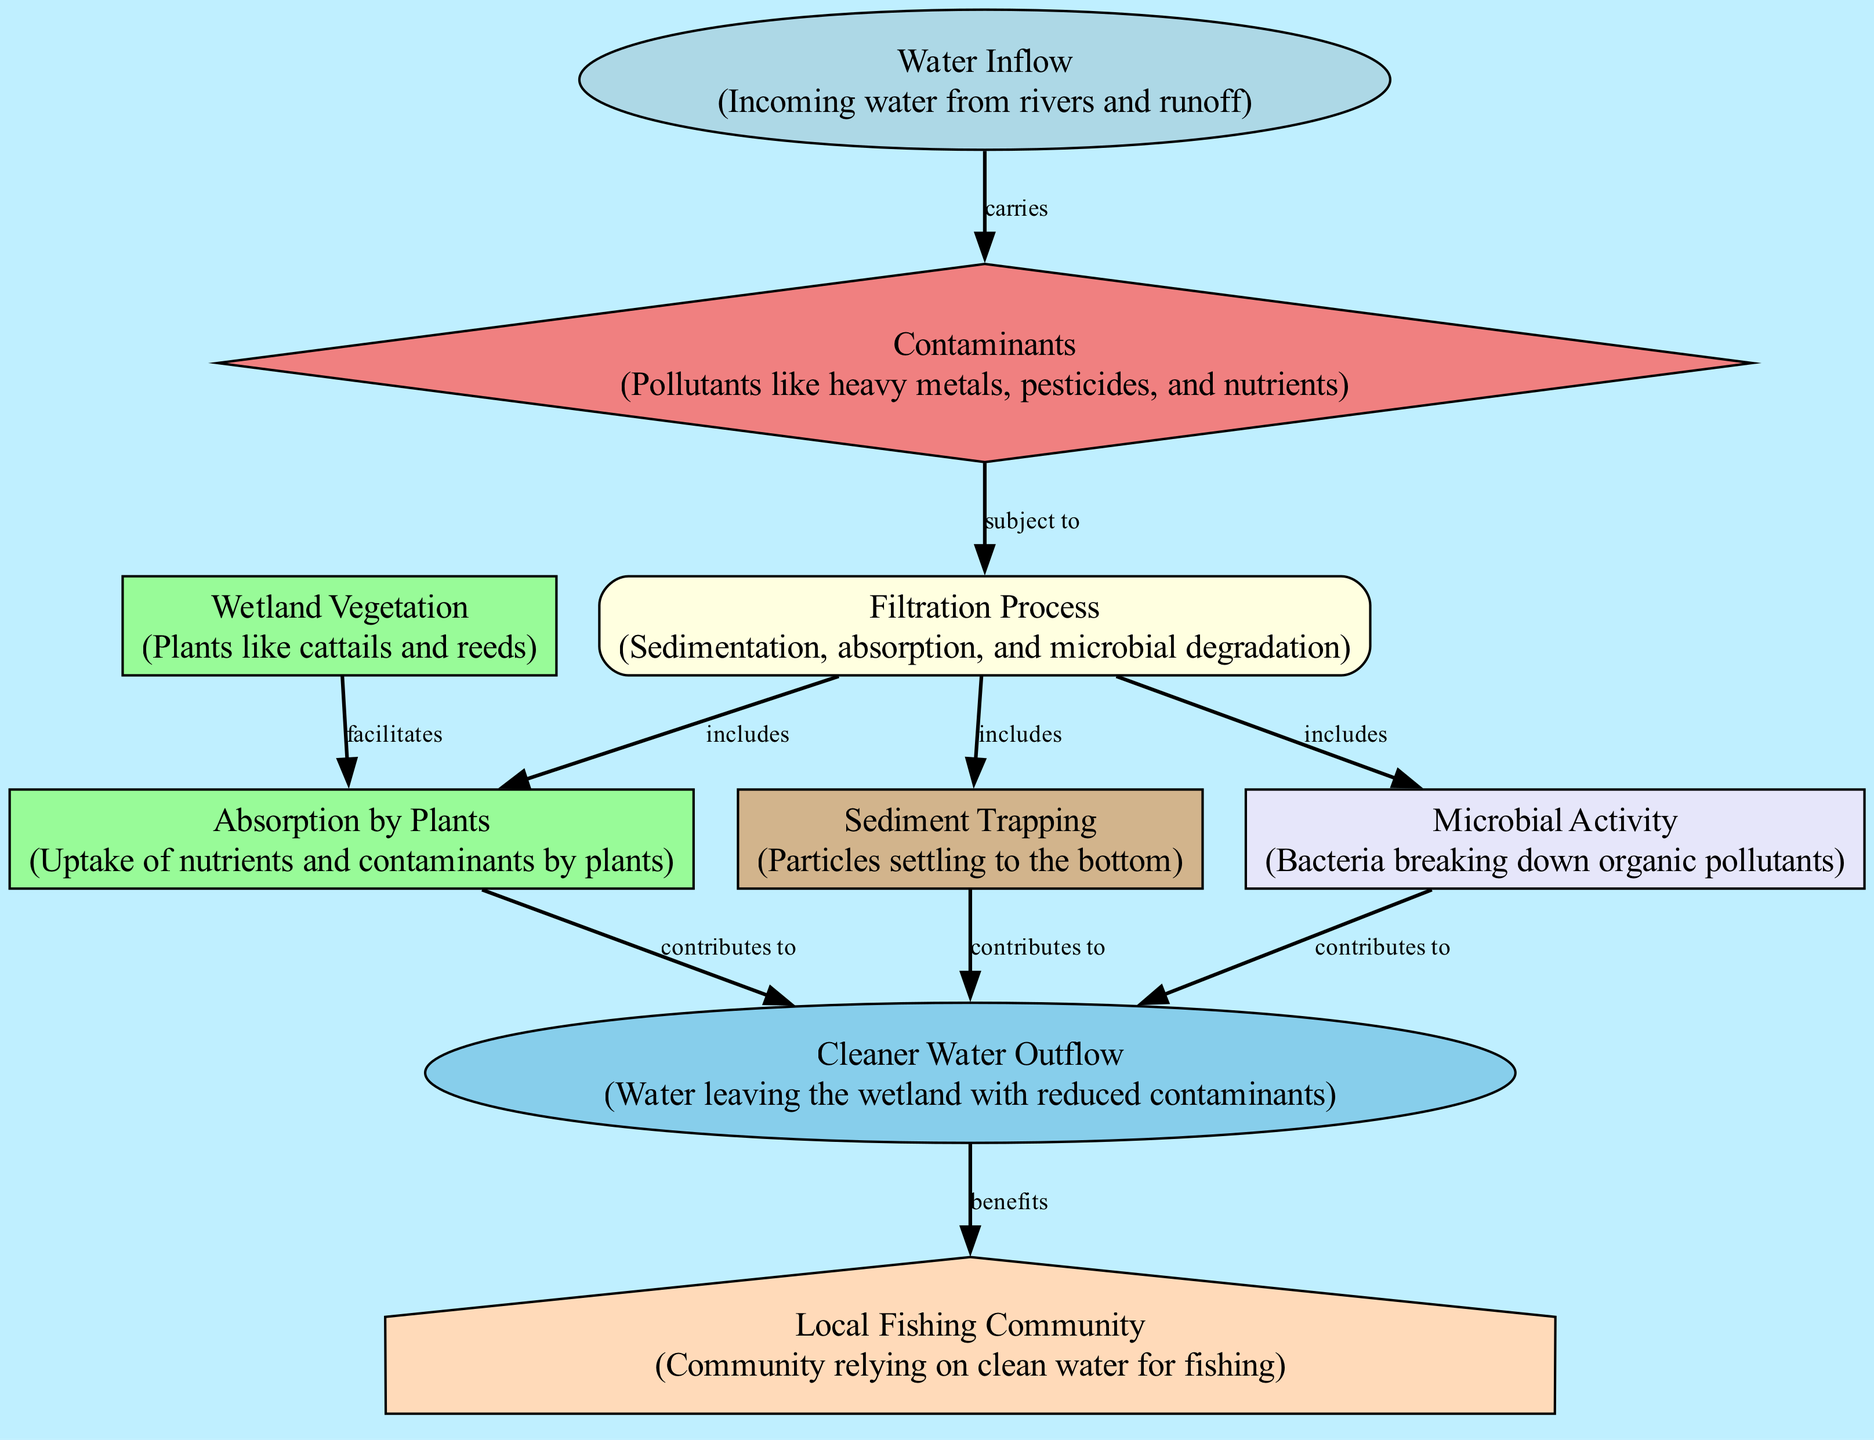What is the first element that incoming water carries? The diagram indicates that the "Water Inflow" node carries the "Contaminants" node, meaning contaminants are found in the inflow of water.
Answer: Contaminants How many filtration processes are included? There are three processes listed under the "Filtration Process" node: Sedimentation, Absorption by Plants, and Microbial Activity. Therefore, there are three filtration processes.
Answer: Three What does the wetland vegetation facilitate? According to the diagram, "Wetland Vegetation" facilitates "Absorption by Plants," indicating that the plants help absorb nutrients and contaminants in the water.
Answer: Absorption by Plants What does sediment trapping contribute to? The "Sediment Trapping" node contributes to "Cleaner Water Outflow," meaning that the process of trapping sediment in the wetland leads to cleaner water being released.
Answer: Cleaner Water Outflow What benefits from the cleaner water outflow? The diagram shows that the "Local Fishing Community" benefits from the "Cleaner Water Outflow," illustrating the direct relationship between clean water and the fishing community's well-being.
Answer: Local Fishing Community Which component is involved in breaking down organic pollutants? The "Microbial Activity" node specifically deals with bacteria that break down organic pollutants, indicating their role in the filtration and purification process.
Answer: Microbial Activity What is the role of the filtration process? The "Filtration Process" encompasses several actions (sedimentation, absorption, and microbial degradation) that work together to filter contaminants from the incoming water.
Answer: Filters contaminants How does water inflow interact with contaminants? The "Water Inflow" directly carries "Contaminants," establishing a direct relationship that indicates the contaminants are part of the water entering the wetland system.
Answer: Carries What is the purpose of the wetland? The overall diagram illustrates that the purpose of the wetland is to filter contaminants and protect local water sources, particularly indicated by the benefits to the fishing community.
Answer: Filter contaminants and protect local water sources 